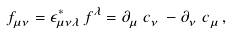<formula> <loc_0><loc_0><loc_500><loc_500>f ^ { \ } _ { \mu \nu } = \epsilon _ { \mu \nu \lambda } ^ { * } \, f ^ { \lambda } = \partial ^ { \ } _ { \mu } c ^ { \ } _ { \nu } - \partial ^ { \ } _ { \nu } c ^ { \ } _ { \mu } ,</formula> 